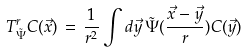Convert formula to latex. <formula><loc_0><loc_0><loc_500><loc_500>T _ { \tilde { \Psi } } ^ { r } C ( \vec { x } ) \, = \, \frac { 1 } { r ^ { 2 } } \int d \vec { y } \, \tilde { \Psi } ( \frac { \vec { x } - \vec { y } } { r } ) C ( \vec { y } )</formula> 